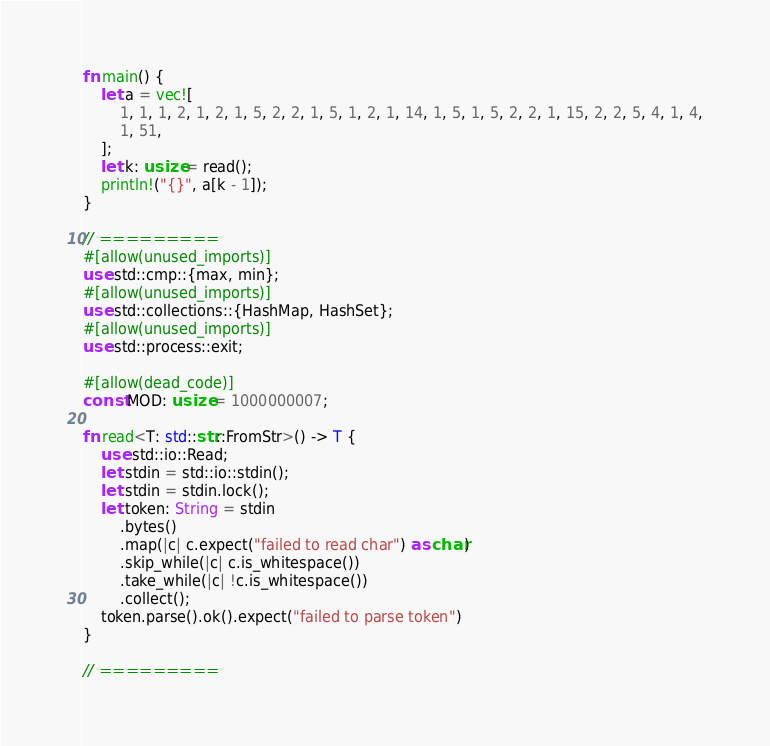Convert code to text. <code><loc_0><loc_0><loc_500><loc_500><_Rust_>fn main() {
    let a = vec![
        1, 1, 1, 2, 1, 2, 1, 5, 2, 2, 1, 5, 1, 2, 1, 14, 1, 5, 1, 5, 2, 2, 1, 15, 2, 2, 5, 4, 1, 4,
        1, 51,
    ];
    let k: usize = read();
    println!("{}", a[k - 1]);
}

// =========
#[allow(unused_imports)]
use std::cmp::{max, min};
#[allow(unused_imports)]
use std::collections::{HashMap, HashSet};
#[allow(unused_imports)]
use std::process::exit;

#[allow(dead_code)]
const MOD: usize = 1000000007;

fn read<T: std::str::FromStr>() -> T {
    use std::io::Read;
    let stdin = std::io::stdin();
    let stdin = stdin.lock();
    let token: String = stdin
        .bytes()
        .map(|c| c.expect("failed to read char") as char)
        .skip_while(|c| c.is_whitespace())
        .take_while(|c| !c.is_whitespace())
        .collect();
    token.parse().ok().expect("failed to parse token")
}

// =========
</code> 